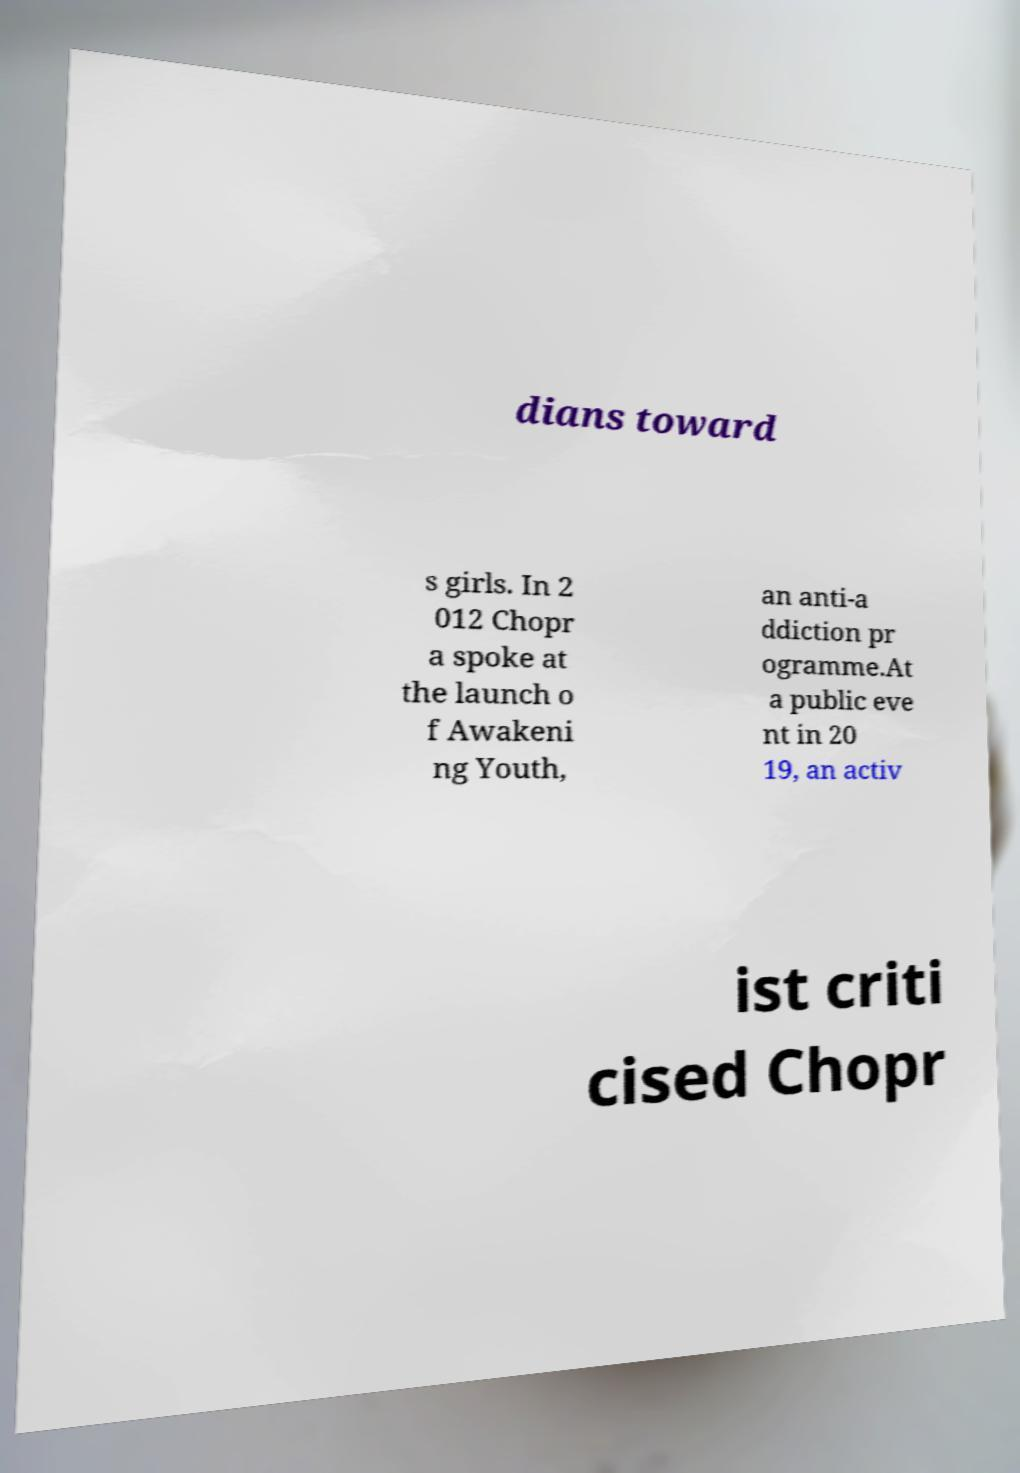What messages or text are displayed in this image? I need them in a readable, typed format. dians toward s girls. In 2 012 Chopr a spoke at the launch o f Awakeni ng Youth, an anti-a ddiction pr ogramme.At a public eve nt in 20 19, an activ ist criti cised Chopr 